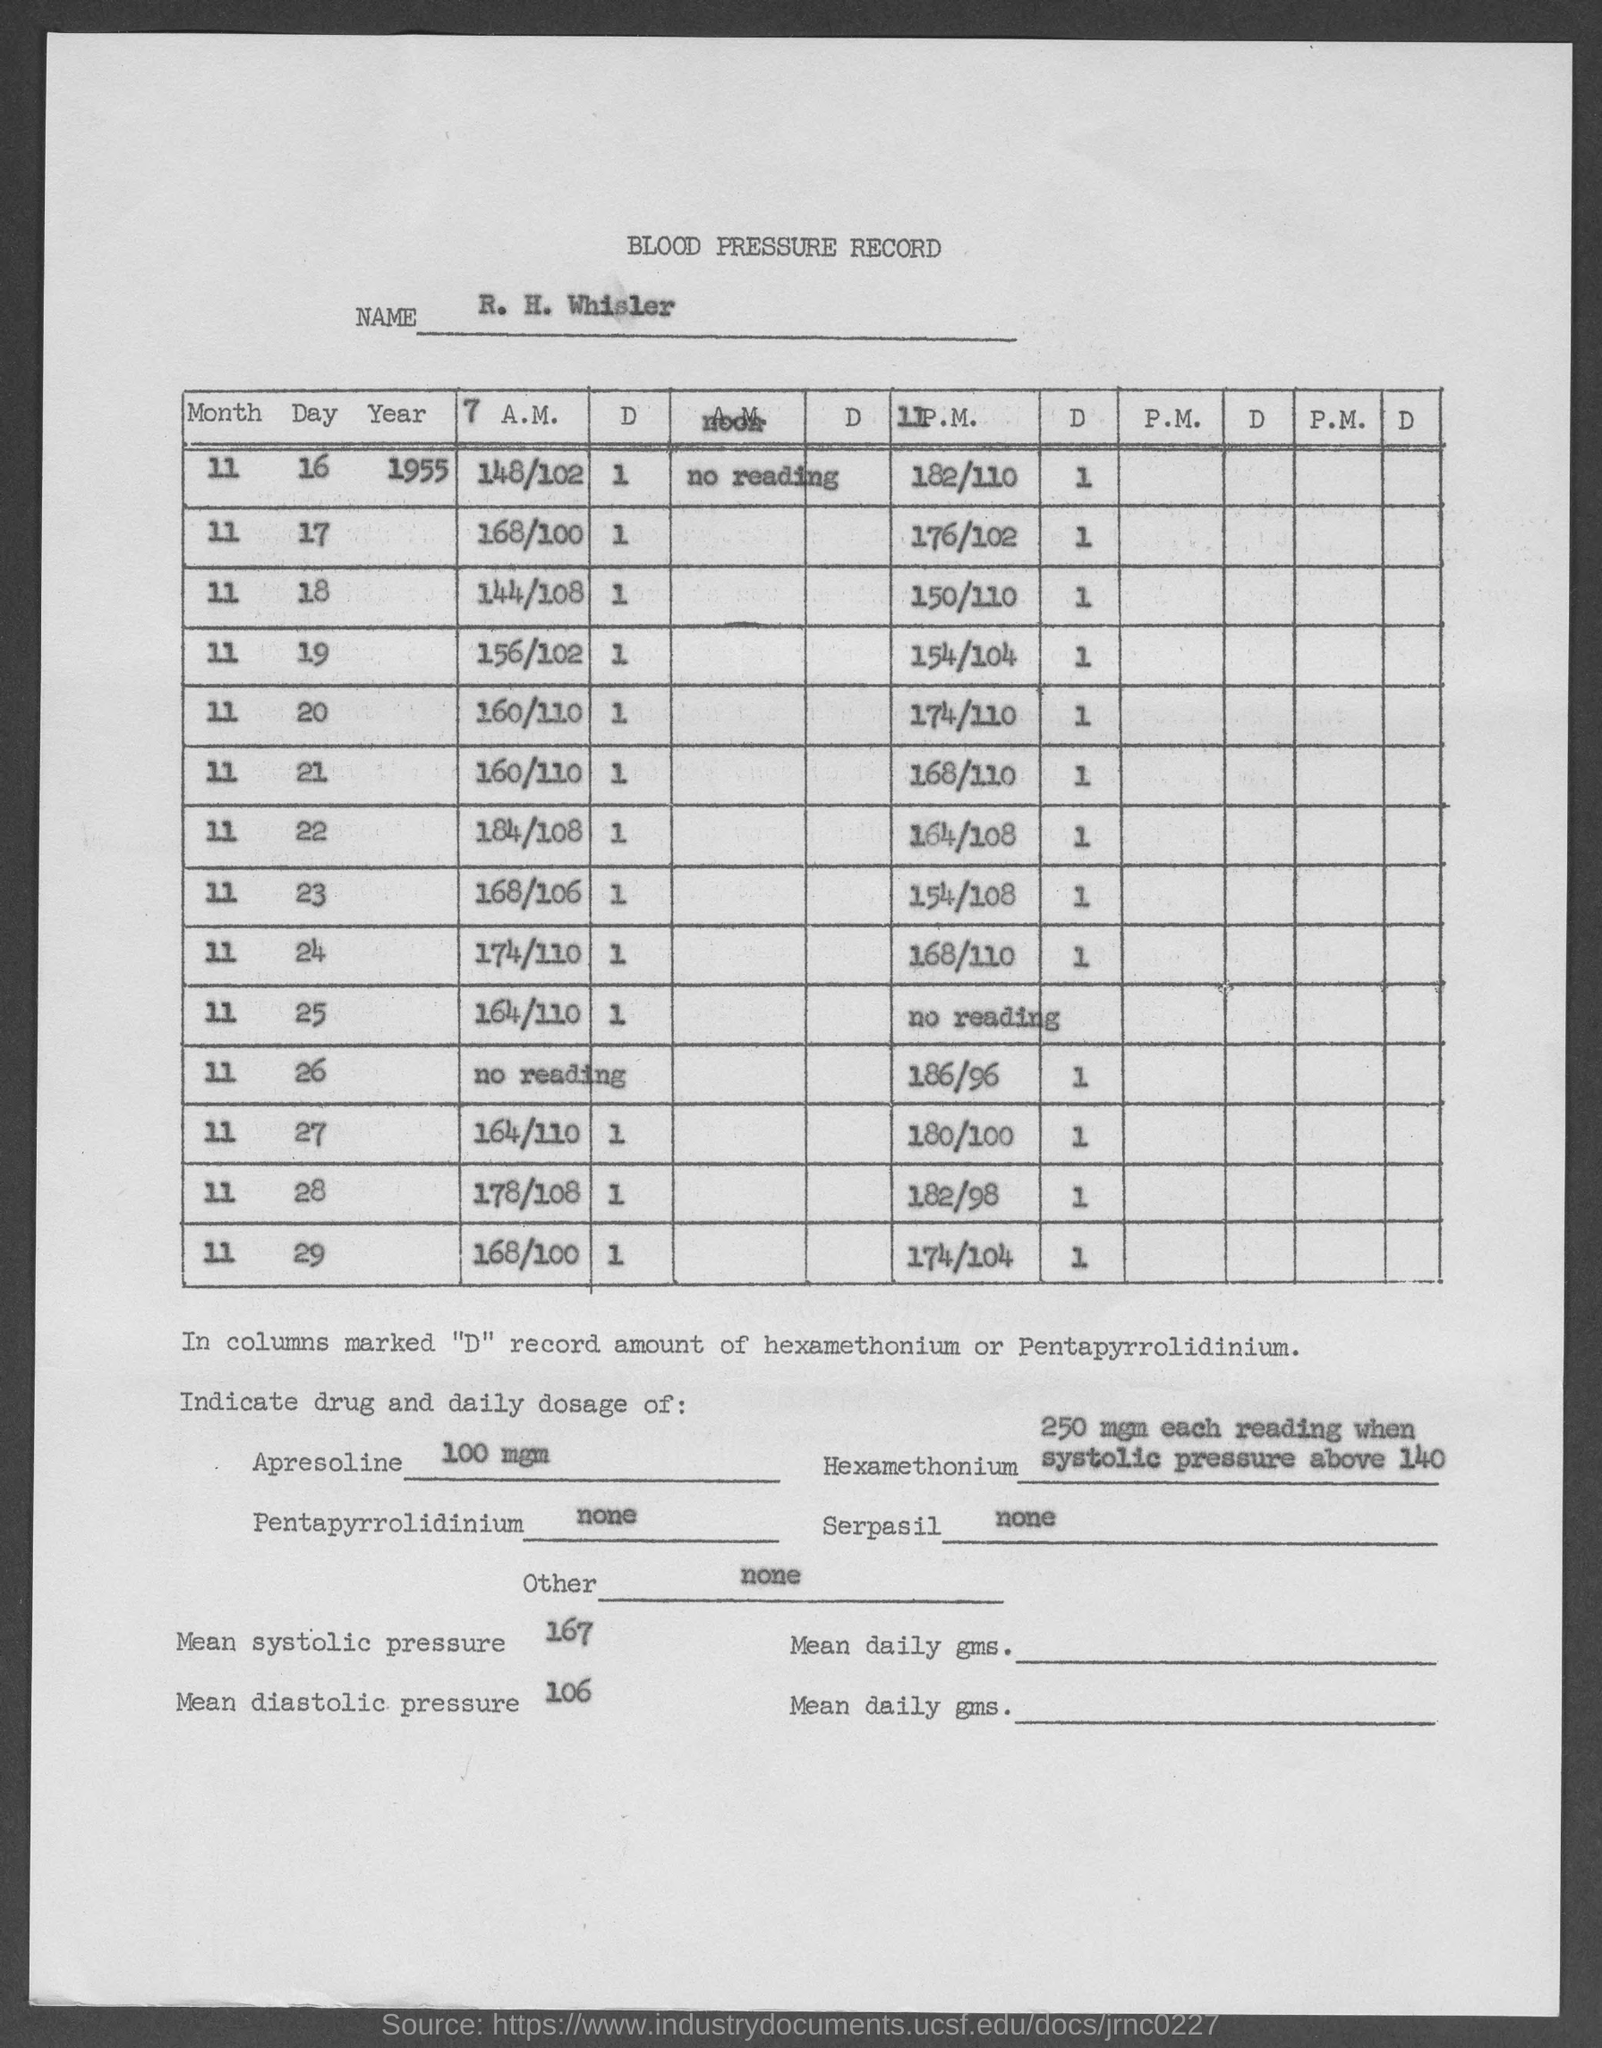What is the Title of the document?
Keep it short and to the point. Blood Pressure Record. What is the daily dosage for Apresoline?
Make the answer very short. 100 mgm. What is the daily dosage for Pentapyrrolidinium?
Offer a terse response. None. What is the daily dosage for Serpasil?
Give a very brief answer. None. What is the mean systolic pressure?
Offer a terse response. 167. What is the mean diastolic pressure?
Provide a succinct answer. 106. What is the daily dosage for Other?
Provide a succinct answer. None. 